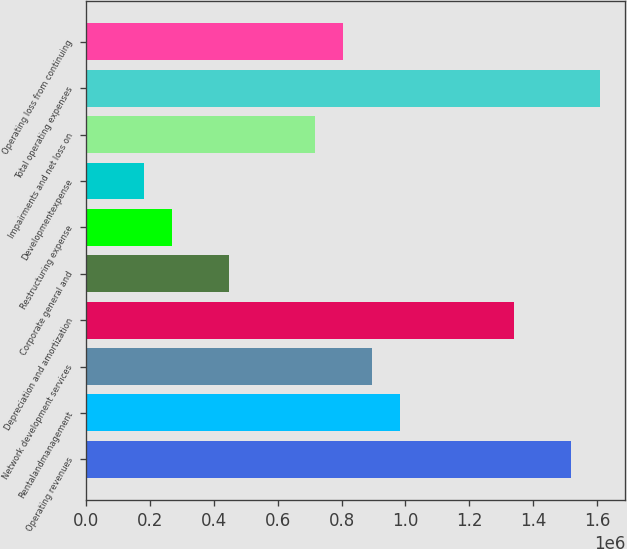<chart> <loc_0><loc_0><loc_500><loc_500><bar_chart><fcel>Operating revenues<fcel>Rentalandmanagement<fcel>Network development services<fcel>Depreciation and amortization<fcel>Corporate general and<fcel>Restructuring expense<fcel>Developmentexpense<fcel>Impairments and net loss on<fcel>Total operating expenses<fcel>Operating loss from continuing<nl><fcel>1.51951e+06<fcel>983960<fcel>894702<fcel>1.34099e+06<fcel>448410<fcel>269893<fcel>180635<fcel>716185<fcel>1.60877e+06<fcel>805444<nl></chart> 